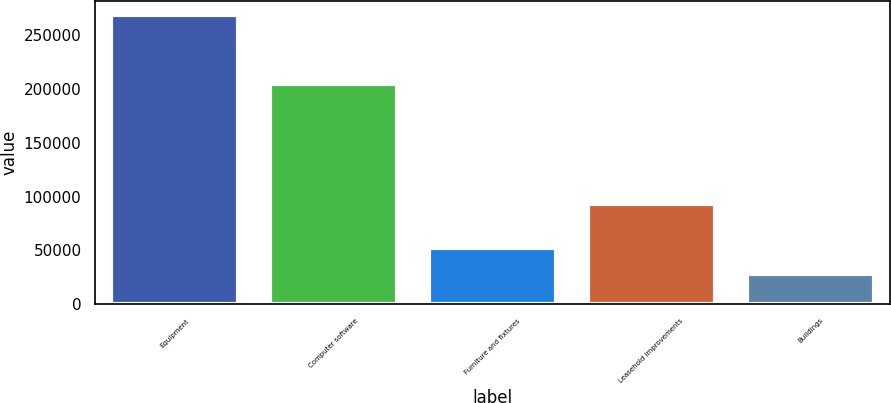<chart> <loc_0><loc_0><loc_500><loc_500><bar_chart><fcel>Equipment<fcel>Computer software<fcel>Furniture and fixtures<fcel>Leasehold improvements<fcel>Buildings<nl><fcel>268472<fcel>204649<fcel>52134.5<fcel>92767<fcel>28097<nl></chart> 